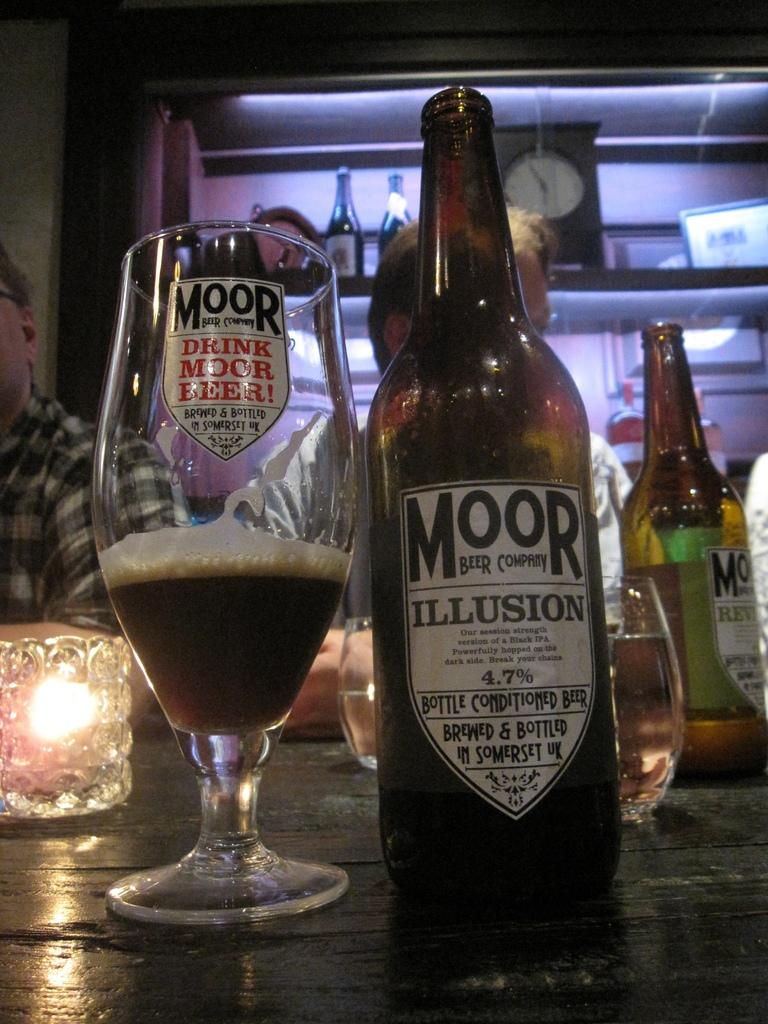<image>
Render a clear and concise summary of the photo. A bottle of Moor beer is next to a glass that has a pun about the company on it. 